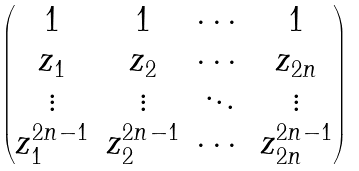<formula> <loc_0><loc_0><loc_500><loc_500>\begin{pmatrix} 1 & 1 & \cdots & 1 \\ z _ { 1 } & z _ { 2 } & \cdots & z _ { 2 n } \\ \vdots & \vdots & \ddots & \vdots \\ z _ { 1 } ^ { 2 n - 1 } & z _ { 2 } ^ { 2 n - 1 } & \cdots & z _ { 2 n } ^ { 2 n - 1 } \end{pmatrix}</formula> 